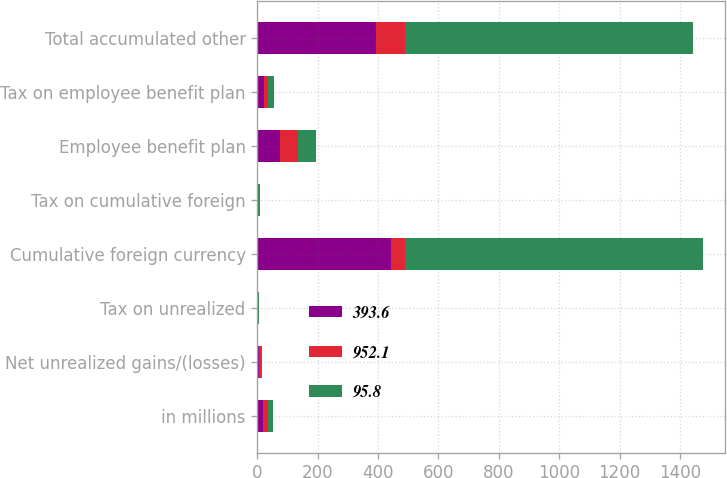<chart> <loc_0><loc_0><loc_500><loc_500><stacked_bar_chart><ecel><fcel>in millions<fcel>Net unrealized gains/(losses)<fcel>Tax on unrealized<fcel>Cumulative foreign currency<fcel>Tax on cumulative foreign<fcel>Employee benefit plan<fcel>Tax on employee benefit plan<fcel>Total accumulated other<nl><fcel>393.6<fcel>17.6<fcel>5.4<fcel>1.6<fcel>442<fcel>2<fcel>74.5<fcel>20.3<fcel>393.6<nl><fcel>952.1<fcel>17.6<fcel>7.7<fcel>0.1<fcel>46.3<fcel>1.3<fcel>59.4<fcel>16.2<fcel>95.8<nl><fcel>95.8<fcel>17.6<fcel>1.6<fcel>2.2<fcel>987.9<fcel>6.3<fcel>59.1<fcel>17.6<fcel>952.1<nl></chart> 